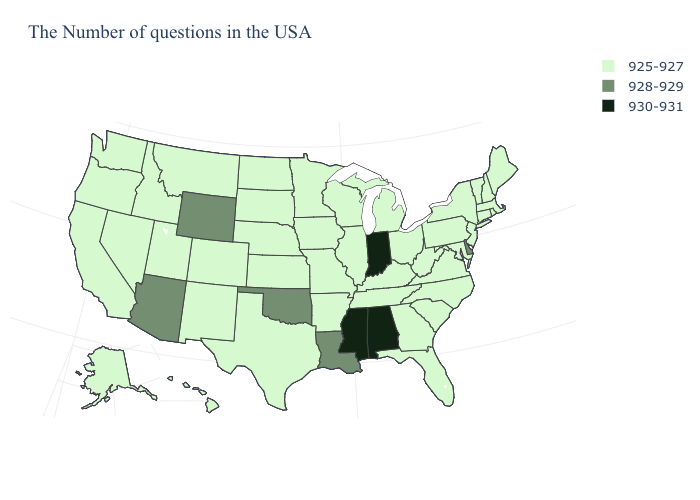What is the value of Pennsylvania?
Write a very short answer. 925-927. What is the value of Texas?
Give a very brief answer. 925-927. Which states have the lowest value in the South?
Concise answer only. Maryland, Virginia, North Carolina, South Carolina, West Virginia, Florida, Georgia, Kentucky, Tennessee, Arkansas, Texas. What is the value of Connecticut?
Answer briefly. 925-927. What is the value of Georgia?
Give a very brief answer. 925-927. What is the value of Iowa?
Write a very short answer. 925-927. What is the highest value in the USA?
Quick response, please. 930-931. Does Connecticut have a lower value than Florida?
Give a very brief answer. No. What is the value of New Mexico?
Short answer required. 925-927. Name the states that have a value in the range 928-929?
Short answer required. Delaware, Louisiana, Oklahoma, Wyoming, Arizona. Name the states that have a value in the range 928-929?
Short answer required. Delaware, Louisiana, Oklahoma, Wyoming, Arizona. Name the states that have a value in the range 925-927?
Give a very brief answer. Maine, Massachusetts, Rhode Island, New Hampshire, Vermont, Connecticut, New York, New Jersey, Maryland, Pennsylvania, Virginia, North Carolina, South Carolina, West Virginia, Ohio, Florida, Georgia, Michigan, Kentucky, Tennessee, Wisconsin, Illinois, Missouri, Arkansas, Minnesota, Iowa, Kansas, Nebraska, Texas, South Dakota, North Dakota, Colorado, New Mexico, Utah, Montana, Idaho, Nevada, California, Washington, Oregon, Alaska, Hawaii. What is the value of Arkansas?
Quick response, please. 925-927. What is the value of Colorado?
Give a very brief answer. 925-927. 